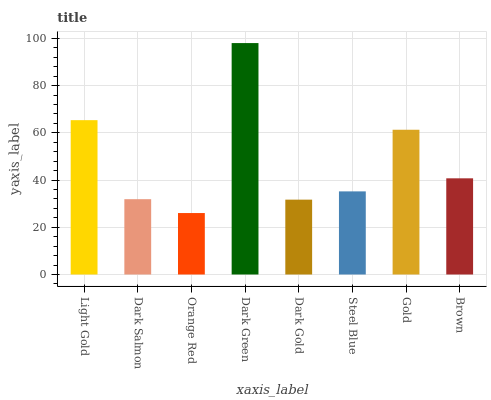Is Dark Salmon the minimum?
Answer yes or no. No. Is Dark Salmon the maximum?
Answer yes or no. No. Is Light Gold greater than Dark Salmon?
Answer yes or no. Yes. Is Dark Salmon less than Light Gold?
Answer yes or no. Yes. Is Dark Salmon greater than Light Gold?
Answer yes or no. No. Is Light Gold less than Dark Salmon?
Answer yes or no. No. Is Brown the high median?
Answer yes or no. Yes. Is Steel Blue the low median?
Answer yes or no. Yes. Is Light Gold the high median?
Answer yes or no. No. Is Gold the low median?
Answer yes or no. No. 